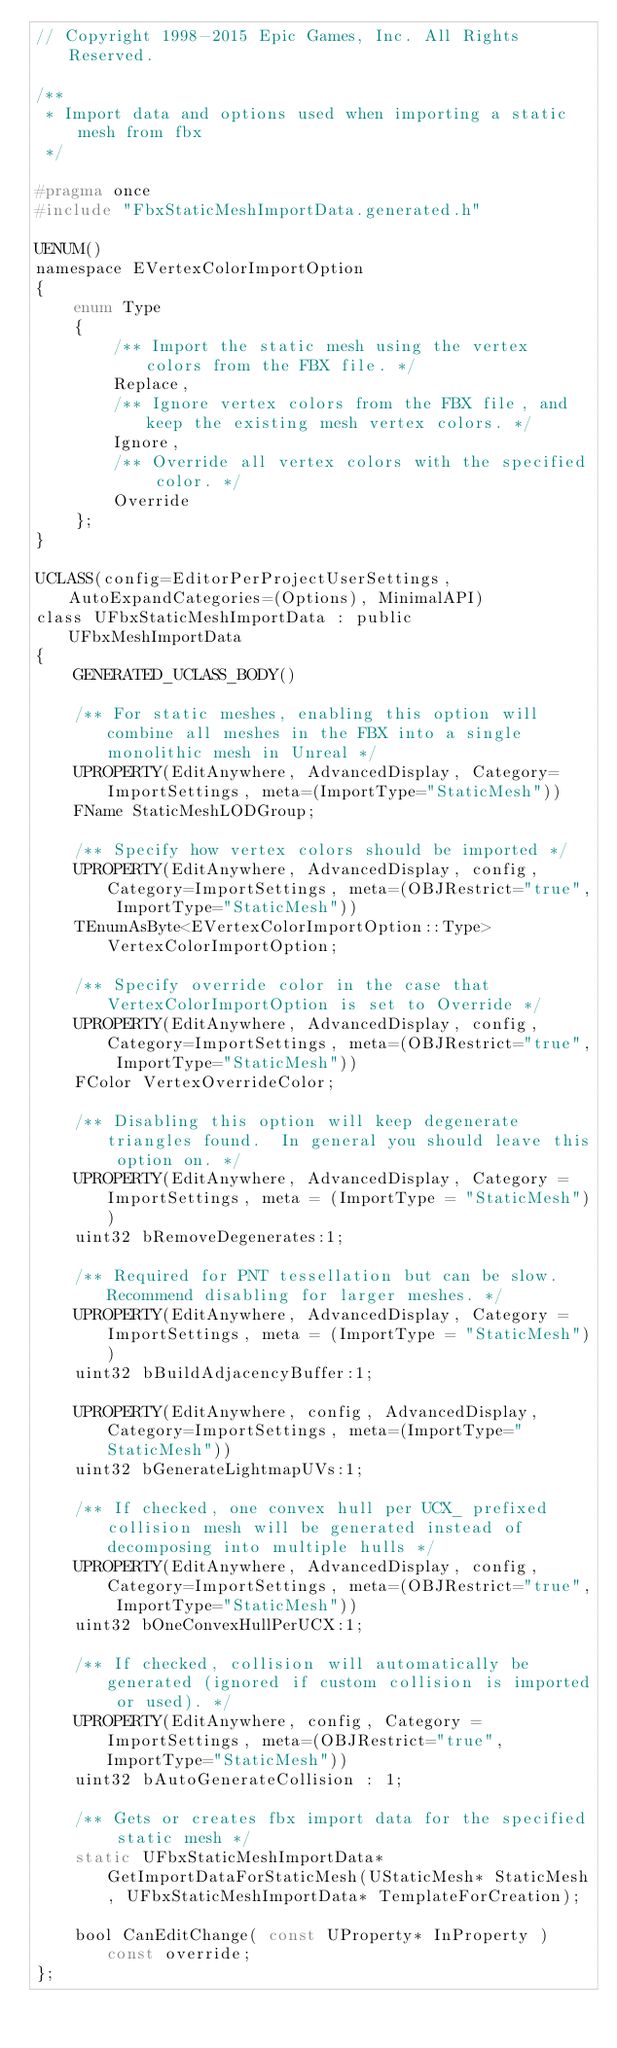<code> <loc_0><loc_0><loc_500><loc_500><_C_>// Copyright 1998-2015 Epic Games, Inc. All Rights Reserved.

/**
 * Import data and options used when importing a static mesh from fbx
 */

#pragma once
#include "FbxStaticMeshImportData.generated.h"

UENUM()
namespace EVertexColorImportOption
{
	enum Type
	{
		/** Import the static mesh using the vertex colors from the FBX file. */
		Replace,
		/** Ignore vertex colors from the FBX file, and keep the existing mesh vertex colors. */
		Ignore,
		/** Override all vertex colors with the specified color. */
		Override
	};
}

UCLASS(config=EditorPerProjectUserSettings, AutoExpandCategories=(Options), MinimalAPI)
class UFbxStaticMeshImportData : public UFbxMeshImportData
{
	GENERATED_UCLASS_BODY()

	/** For static meshes, enabling this option will combine all meshes in the FBX into a single monolithic mesh in Unreal */
	UPROPERTY(EditAnywhere, AdvancedDisplay, Category=ImportSettings, meta=(ImportType="StaticMesh"))
	FName StaticMeshLODGroup;

	/** Specify how vertex colors should be imported */
	UPROPERTY(EditAnywhere, AdvancedDisplay, config, Category=ImportSettings, meta=(OBJRestrict="true", ImportType="StaticMesh"))
	TEnumAsByte<EVertexColorImportOption::Type> VertexColorImportOption;

	/** Specify override color in the case that VertexColorImportOption is set to Override */
	UPROPERTY(EditAnywhere, AdvancedDisplay, config, Category=ImportSettings, meta=(OBJRestrict="true", ImportType="StaticMesh"))
	FColor VertexOverrideColor;

	/** Disabling this option will keep degenerate triangles found.  In general you should leave this option on. */
	UPROPERTY(EditAnywhere, AdvancedDisplay, Category = ImportSettings, meta = (ImportType = "StaticMesh"))
	uint32 bRemoveDegenerates:1;

	/** Required for PNT tessellation but can be slow. Recommend disabling for larger meshes. */
	UPROPERTY(EditAnywhere, AdvancedDisplay, Category = ImportSettings, meta = (ImportType = "StaticMesh"))
	uint32 bBuildAdjacencyBuffer:1;
	
	UPROPERTY(EditAnywhere, config, AdvancedDisplay, Category=ImportSettings, meta=(ImportType="StaticMesh"))
	uint32 bGenerateLightmapUVs:1;

	/** If checked, one convex hull per UCX_ prefixed collision mesh will be generated instead of decomposing into multiple hulls */
	UPROPERTY(EditAnywhere, AdvancedDisplay, config, Category=ImportSettings, meta=(OBJRestrict="true", ImportType="StaticMesh"))
	uint32 bOneConvexHullPerUCX:1;

	/** If checked, collision will automatically be generated (ignored if custom collision is imported or used). */
	UPROPERTY(EditAnywhere, config, Category = ImportSettings, meta=(OBJRestrict="true", ImportType="StaticMesh"))
	uint32 bAutoGenerateCollision : 1;

	/** Gets or creates fbx import data for the specified static mesh */
	static UFbxStaticMeshImportData* GetImportDataForStaticMesh(UStaticMesh* StaticMesh, UFbxStaticMeshImportData* TemplateForCreation);

	bool CanEditChange( const UProperty* InProperty ) const override;
};



</code> 